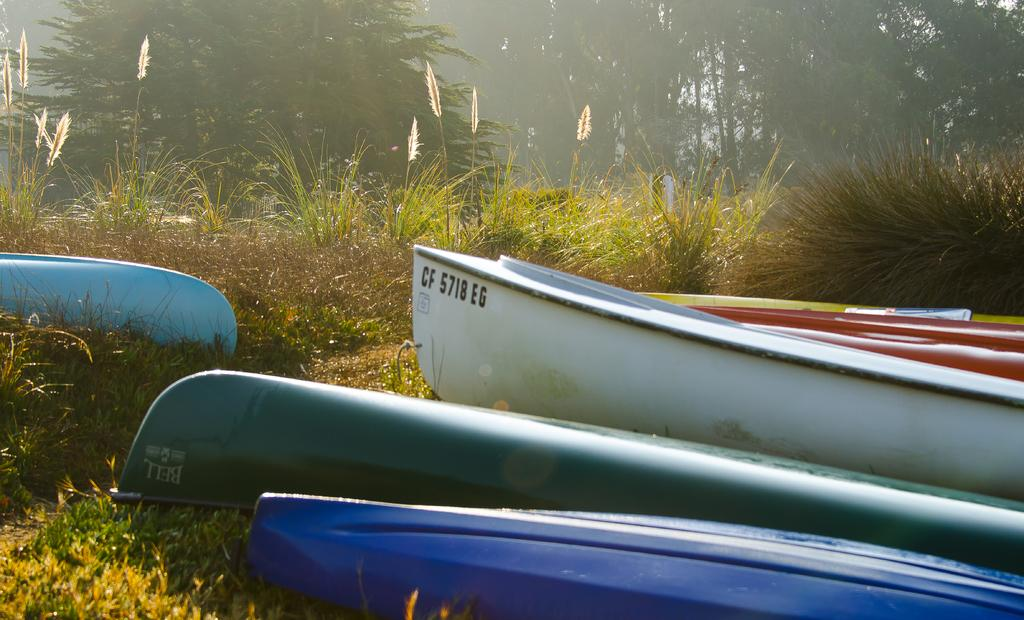What type of vehicles can be seen in the image? There are boats in the image. What other elements are present in the image besides the boats? There are plants and trees in the image. What type of humor can be found in the picture? There is no picture present in the image, and therefore no humor can be found. What is the purpose of the hammer in the image? There is no hammer present in the image. 